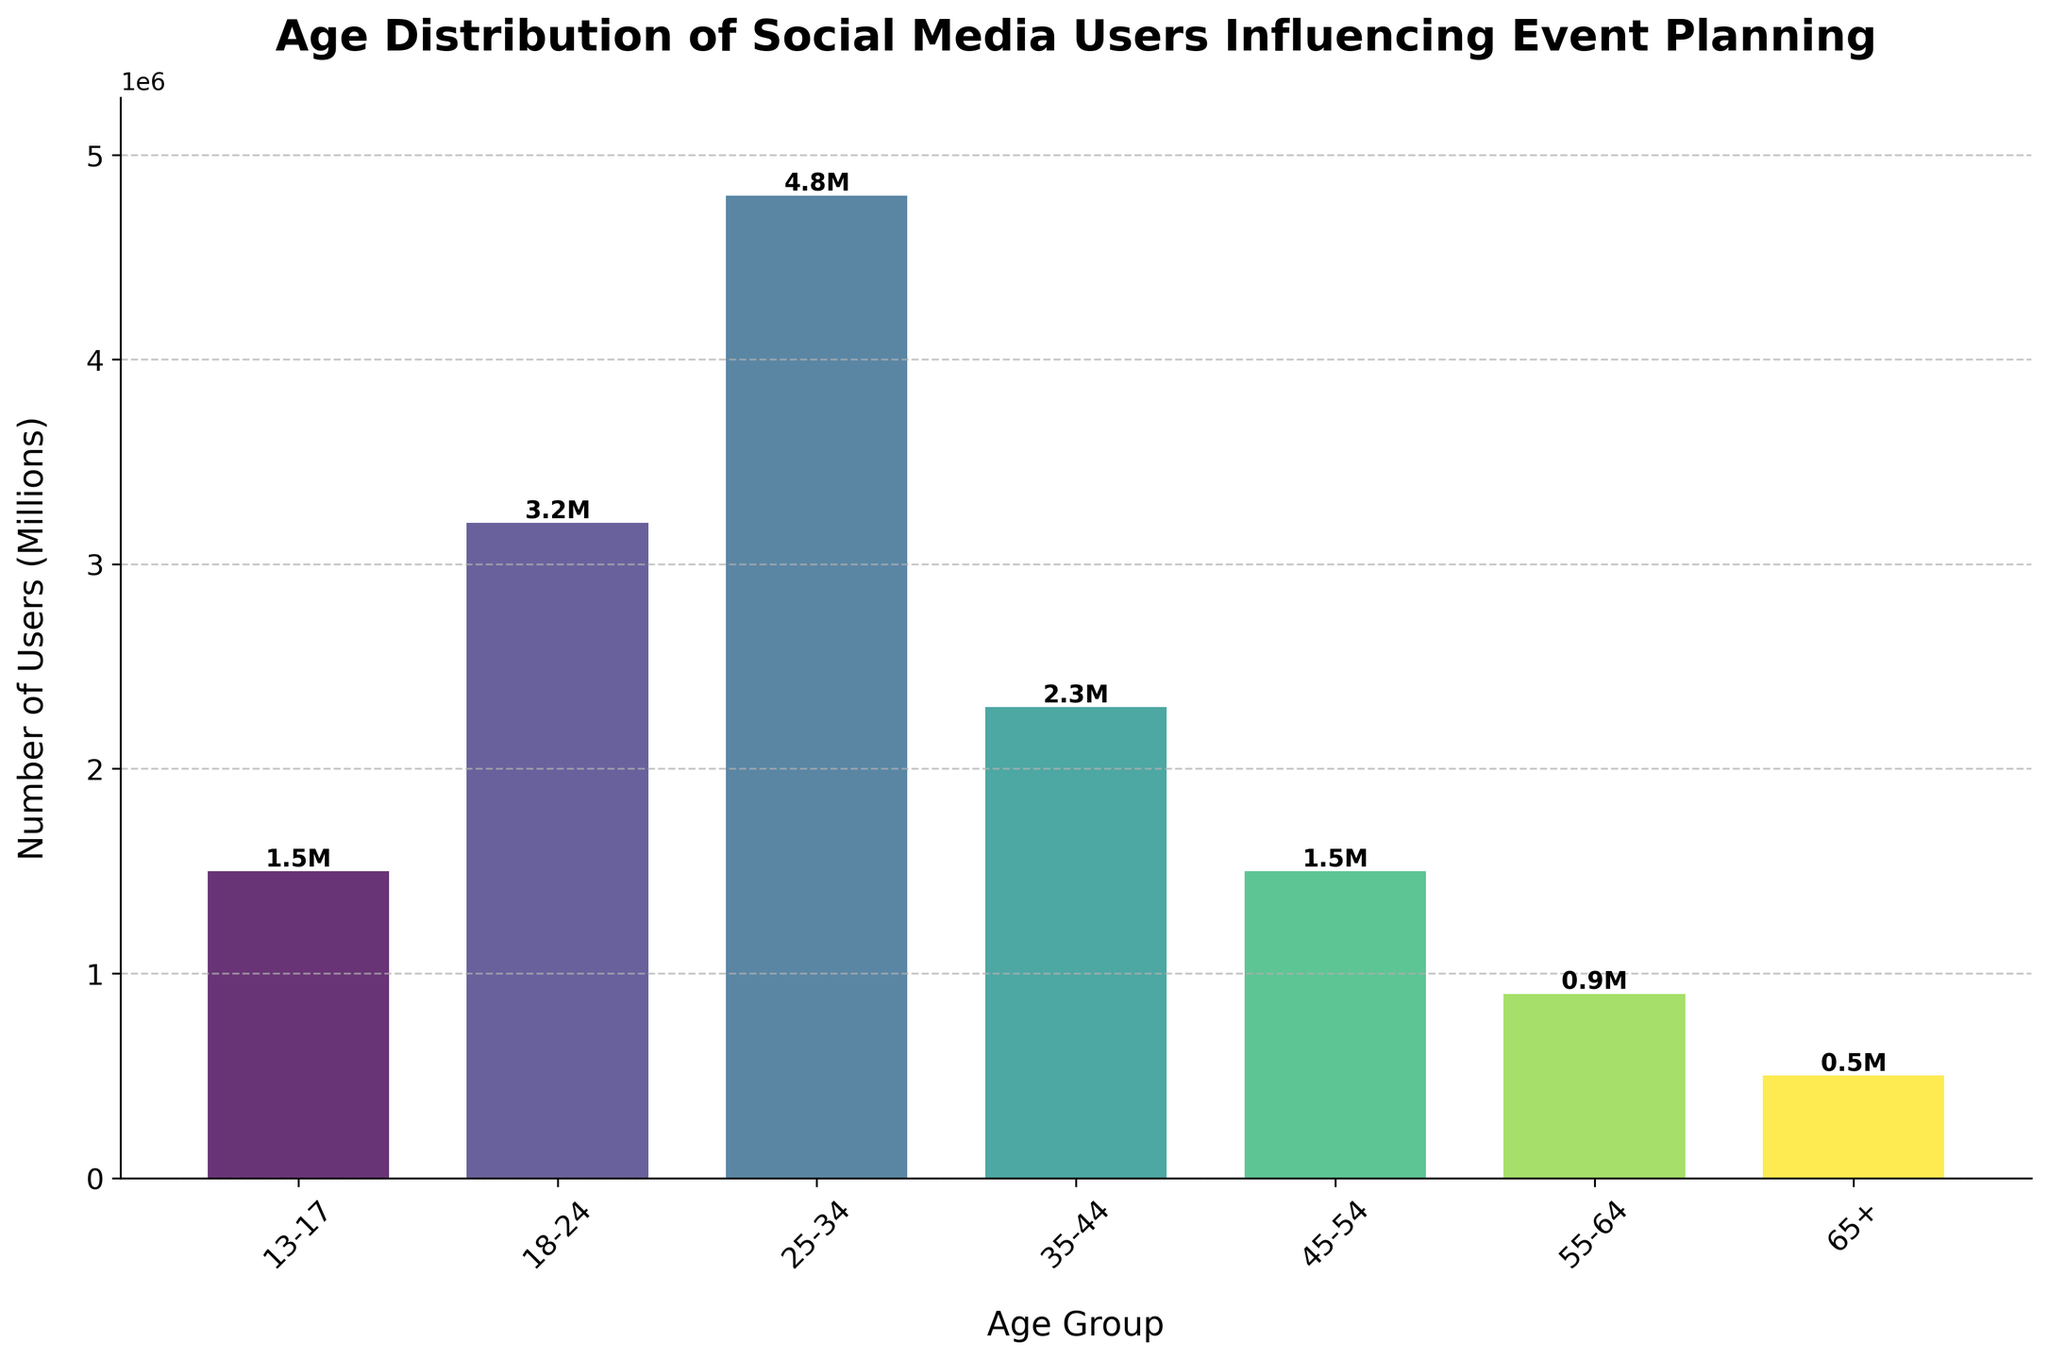What is the title of the figure? The title is written at the top of the figure. It reads "Age Distribution of Social Media Users Influencing Event Planning."
Answer: Age Distribution of Social Media Users Influencing Event Planning Which age group has the highest number of social media users? By looking at the heights of the bars, we can see that the age group 25-34 has the highest bar, indicating the highest number of users.
Answer: 25-34 What are the labels on the x-axis? The x-axis labels show the different age groups. These are "13-17", "18-24", "25-34", "35-44", "45-54", "55-64", and "65+."
Answer: 13-17, 18-24, 25-34, 35-44, 45-54, 55-64, 65+ What's the total number of users in the age groups above 50? We sum the values for the age groups 50 and above: 45-54 (1.5M), 55-64 (0.9M), and 65+ (0.5M). Total is 1.5M + 0.9M + 0.5M = 2.9M.
Answer: 2.9M How does the number of users in the 18-24 age group compare to the number of users in the 35-44 age group? The number of users in the 18-24 age group is 3.2 million, while in the 35-44 age group it is 2.3 million. Comparing these values, the 18-24 age group has more users.
Answer: The 18-24 age group has more users Which age group has the least number of social media users? The shortest bar represents the age group with the least number of users. The age group 65+ has the shortest bar.
Answer: 65+ What fraction of the total users are in the 25-34 age group? The number of users in the 25-34 age group is 4.8 million. The total number of users is the sum of all the groups: 1.5M + 3.2M + 4.8M + 2.3M + 1.5M + 0.9M + 0.5M = 14.7M. The fraction is 4.8M / 14.7M.
Answer: 4.8/14.7 What’s the approximate percentage of users in the 13-17 age group? The number of users in the 13-17 age group is 1.5 million. The total number of users is 14.7 million. The percentage is (1.5M / 14.7M) * 100%.
Answer: Approximately 10.2% How much taller is the bar for 25-34 compared to the bar for 45-54? The number of users for 25-34 is 4.8 million and for 45-54 it is 1.5 million. The height difference of the bars is 4.8M - 1.5M = 3.3M.
Answer: 3.3M 